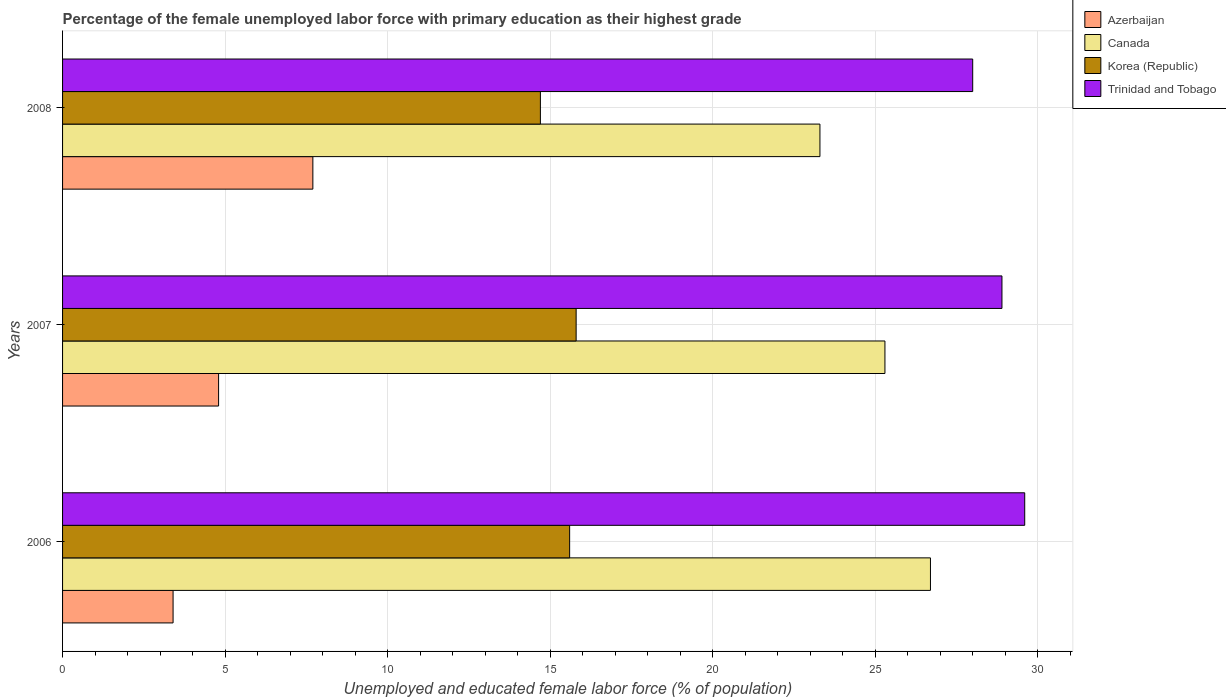Are the number of bars on each tick of the Y-axis equal?
Offer a terse response. Yes. What is the label of the 2nd group of bars from the top?
Keep it short and to the point. 2007. What is the percentage of the unemployed female labor force with primary education in Azerbaijan in 2007?
Your answer should be very brief. 4.8. Across all years, what is the maximum percentage of the unemployed female labor force with primary education in Azerbaijan?
Your answer should be compact. 7.7. What is the total percentage of the unemployed female labor force with primary education in Canada in the graph?
Your answer should be very brief. 75.3. What is the difference between the percentage of the unemployed female labor force with primary education in Trinidad and Tobago in 2006 and that in 2008?
Your answer should be very brief. 1.6. What is the difference between the percentage of the unemployed female labor force with primary education in Trinidad and Tobago in 2006 and the percentage of the unemployed female labor force with primary education in Canada in 2007?
Make the answer very short. 4.3. What is the average percentage of the unemployed female labor force with primary education in Korea (Republic) per year?
Offer a very short reply. 15.37. In the year 2008, what is the difference between the percentage of the unemployed female labor force with primary education in Trinidad and Tobago and percentage of the unemployed female labor force with primary education in Korea (Republic)?
Your answer should be compact. 13.3. In how many years, is the percentage of the unemployed female labor force with primary education in Canada greater than 4 %?
Your answer should be very brief. 3. What is the ratio of the percentage of the unemployed female labor force with primary education in Azerbaijan in 2006 to that in 2008?
Your answer should be very brief. 0.44. What is the difference between the highest and the second highest percentage of the unemployed female labor force with primary education in Canada?
Your answer should be very brief. 1.4. What is the difference between the highest and the lowest percentage of the unemployed female labor force with primary education in Azerbaijan?
Ensure brevity in your answer.  4.3. In how many years, is the percentage of the unemployed female labor force with primary education in Azerbaijan greater than the average percentage of the unemployed female labor force with primary education in Azerbaijan taken over all years?
Provide a short and direct response. 1. Is the sum of the percentage of the unemployed female labor force with primary education in Canada in 2007 and 2008 greater than the maximum percentage of the unemployed female labor force with primary education in Azerbaijan across all years?
Provide a succinct answer. Yes. What does the 3rd bar from the top in 2008 represents?
Offer a terse response. Canada. How many bars are there?
Your response must be concise. 12. Are all the bars in the graph horizontal?
Provide a succinct answer. Yes. Does the graph contain any zero values?
Provide a short and direct response. No. Where does the legend appear in the graph?
Your answer should be compact. Top right. How many legend labels are there?
Keep it short and to the point. 4. What is the title of the graph?
Your answer should be compact. Percentage of the female unemployed labor force with primary education as their highest grade. Does "Grenada" appear as one of the legend labels in the graph?
Offer a terse response. No. What is the label or title of the X-axis?
Make the answer very short. Unemployed and educated female labor force (% of population). What is the label or title of the Y-axis?
Your answer should be compact. Years. What is the Unemployed and educated female labor force (% of population) in Azerbaijan in 2006?
Keep it short and to the point. 3.4. What is the Unemployed and educated female labor force (% of population) of Canada in 2006?
Give a very brief answer. 26.7. What is the Unemployed and educated female labor force (% of population) in Korea (Republic) in 2006?
Your response must be concise. 15.6. What is the Unemployed and educated female labor force (% of population) in Trinidad and Tobago in 2006?
Offer a very short reply. 29.6. What is the Unemployed and educated female labor force (% of population) in Azerbaijan in 2007?
Ensure brevity in your answer.  4.8. What is the Unemployed and educated female labor force (% of population) in Canada in 2007?
Offer a terse response. 25.3. What is the Unemployed and educated female labor force (% of population) in Korea (Republic) in 2007?
Provide a succinct answer. 15.8. What is the Unemployed and educated female labor force (% of population) of Trinidad and Tobago in 2007?
Your answer should be compact. 28.9. What is the Unemployed and educated female labor force (% of population) in Azerbaijan in 2008?
Your answer should be very brief. 7.7. What is the Unemployed and educated female labor force (% of population) of Canada in 2008?
Provide a succinct answer. 23.3. What is the Unemployed and educated female labor force (% of population) of Korea (Republic) in 2008?
Your answer should be very brief. 14.7. What is the Unemployed and educated female labor force (% of population) in Trinidad and Tobago in 2008?
Keep it short and to the point. 28. Across all years, what is the maximum Unemployed and educated female labor force (% of population) in Azerbaijan?
Your answer should be very brief. 7.7. Across all years, what is the maximum Unemployed and educated female labor force (% of population) in Canada?
Offer a terse response. 26.7. Across all years, what is the maximum Unemployed and educated female labor force (% of population) of Korea (Republic)?
Make the answer very short. 15.8. Across all years, what is the maximum Unemployed and educated female labor force (% of population) of Trinidad and Tobago?
Offer a very short reply. 29.6. Across all years, what is the minimum Unemployed and educated female labor force (% of population) in Azerbaijan?
Make the answer very short. 3.4. Across all years, what is the minimum Unemployed and educated female labor force (% of population) of Canada?
Make the answer very short. 23.3. Across all years, what is the minimum Unemployed and educated female labor force (% of population) in Korea (Republic)?
Provide a short and direct response. 14.7. Across all years, what is the minimum Unemployed and educated female labor force (% of population) of Trinidad and Tobago?
Ensure brevity in your answer.  28. What is the total Unemployed and educated female labor force (% of population) in Canada in the graph?
Provide a short and direct response. 75.3. What is the total Unemployed and educated female labor force (% of population) of Korea (Republic) in the graph?
Provide a succinct answer. 46.1. What is the total Unemployed and educated female labor force (% of population) of Trinidad and Tobago in the graph?
Provide a short and direct response. 86.5. What is the difference between the Unemployed and educated female labor force (% of population) of Canada in 2006 and that in 2007?
Offer a terse response. 1.4. What is the difference between the Unemployed and educated female labor force (% of population) in Korea (Republic) in 2006 and that in 2007?
Ensure brevity in your answer.  -0.2. What is the difference between the Unemployed and educated female labor force (% of population) of Trinidad and Tobago in 2006 and that in 2007?
Ensure brevity in your answer.  0.7. What is the difference between the Unemployed and educated female labor force (% of population) of Azerbaijan in 2006 and that in 2008?
Keep it short and to the point. -4.3. What is the difference between the Unemployed and educated female labor force (% of population) in Canada in 2006 and that in 2008?
Give a very brief answer. 3.4. What is the difference between the Unemployed and educated female labor force (% of population) in Azerbaijan in 2007 and that in 2008?
Ensure brevity in your answer.  -2.9. What is the difference between the Unemployed and educated female labor force (% of population) of Canada in 2007 and that in 2008?
Provide a succinct answer. 2. What is the difference between the Unemployed and educated female labor force (% of population) in Azerbaijan in 2006 and the Unemployed and educated female labor force (% of population) in Canada in 2007?
Your answer should be very brief. -21.9. What is the difference between the Unemployed and educated female labor force (% of population) in Azerbaijan in 2006 and the Unemployed and educated female labor force (% of population) in Trinidad and Tobago in 2007?
Provide a short and direct response. -25.5. What is the difference between the Unemployed and educated female labor force (% of population) of Canada in 2006 and the Unemployed and educated female labor force (% of population) of Korea (Republic) in 2007?
Make the answer very short. 10.9. What is the difference between the Unemployed and educated female labor force (% of population) in Canada in 2006 and the Unemployed and educated female labor force (% of population) in Trinidad and Tobago in 2007?
Your answer should be very brief. -2.2. What is the difference between the Unemployed and educated female labor force (% of population) of Korea (Republic) in 2006 and the Unemployed and educated female labor force (% of population) of Trinidad and Tobago in 2007?
Provide a succinct answer. -13.3. What is the difference between the Unemployed and educated female labor force (% of population) of Azerbaijan in 2006 and the Unemployed and educated female labor force (% of population) of Canada in 2008?
Offer a terse response. -19.9. What is the difference between the Unemployed and educated female labor force (% of population) of Azerbaijan in 2006 and the Unemployed and educated female labor force (% of population) of Korea (Republic) in 2008?
Keep it short and to the point. -11.3. What is the difference between the Unemployed and educated female labor force (% of population) of Azerbaijan in 2006 and the Unemployed and educated female labor force (% of population) of Trinidad and Tobago in 2008?
Your answer should be compact. -24.6. What is the difference between the Unemployed and educated female labor force (% of population) in Canada in 2006 and the Unemployed and educated female labor force (% of population) in Korea (Republic) in 2008?
Keep it short and to the point. 12. What is the difference between the Unemployed and educated female labor force (% of population) of Korea (Republic) in 2006 and the Unemployed and educated female labor force (% of population) of Trinidad and Tobago in 2008?
Ensure brevity in your answer.  -12.4. What is the difference between the Unemployed and educated female labor force (% of population) in Azerbaijan in 2007 and the Unemployed and educated female labor force (% of population) in Canada in 2008?
Offer a terse response. -18.5. What is the difference between the Unemployed and educated female labor force (% of population) in Azerbaijan in 2007 and the Unemployed and educated female labor force (% of population) in Trinidad and Tobago in 2008?
Make the answer very short. -23.2. What is the difference between the Unemployed and educated female labor force (% of population) in Canada in 2007 and the Unemployed and educated female labor force (% of population) in Korea (Republic) in 2008?
Ensure brevity in your answer.  10.6. What is the difference between the Unemployed and educated female labor force (% of population) in Canada in 2007 and the Unemployed and educated female labor force (% of population) in Trinidad and Tobago in 2008?
Give a very brief answer. -2.7. What is the difference between the Unemployed and educated female labor force (% of population) in Korea (Republic) in 2007 and the Unemployed and educated female labor force (% of population) in Trinidad and Tobago in 2008?
Provide a succinct answer. -12.2. What is the average Unemployed and educated female labor force (% of population) in Canada per year?
Keep it short and to the point. 25.1. What is the average Unemployed and educated female labor force (% of population) of Korea (Republic) per year?
Keep it short and to the point. 15.37. What is the average Unemployed and educated female labor force (% of population) in Trinidad and Tobago per year?
Offer a very short reply. 28.83. In the year 2006, what is the difference between the Unemployed and educated female labor force (% of population) in Azerbaijan and Unemployed and educated female labor force (% of population) in Canada?
Your response must be concise. -23.3. In the year 2006, what is the difference between the Unemployed and educated female labor force (% of population) in Azerbaijan and Unemployed and educated female labor force (% of population) in Trinidad and Tobago?
Keep it short and to the point. -26.2. In the year 2006, what is the difference between the Unemployed and educated female labor force (% of population) of Canada and Unemployed and educated female labor force (% of population) of Trinidad and Tobago?
Give a very brief answer. -2.9. In the year 2006, what is the difference between the Unemployed and educated female labor force (% of population) of Korea (Republic) and Unemployed and educated female labor force (% of population) of Trinidad and Tobago?
Offer a terse response. -14. In the year 2007, what is the difference between the Unemployed and educated female labor force (% of population) of Azerbaijan and Unemployed and educated female labor force (% of population) of Canada?
Your answer should be very brief. -20.5. In the year 2007, what is the difference between the Unemployed and educated female labor force (% of population) in Azerbaijan and Unemployed and educated female labor force (% of population) in Trinidad and Tobago?
Offer a very short reply. -24.1. In the year 2007, what is the difference between the Unemployed and educated female labor force (% of population) in Korea (Republic) and Unemployed and educated female labor force (% of population) in Trinidad and Tobago?
Provide a succinct answer. -13.1. In the year 2008, what is the difference between the Unemployed and educated female labor force (% of population) in Azerbaijan and Unemployed and educated female labor force (% of population) in Canada?
Offer a very short reply. -15.6. In the year 2008, what is the difference between the Unemployed and educated female labor force (% of population) of Azerbaijan and Unemployed and educated female labor force (% of population) of Korea (Republic)?
Keep it short and to the point. -7. In the year 2008, what is the difference between the Unemployed and educated female labor force (% of population) in Azerbaijan and Unemployed and educated female labor force (% of population) in Trinidad and Tobago?
Ensure brevity in your answer.  -20.3. In the year 2008, what is the difference between the Unemployed and educated female labor force (% of population) of Canada and Unemployed and educated female labor force (% of population) of Trinidad and Tobago?
Give a very brief answer. -4.7. What is the ratio of the Unemployed and educated female labor force (% of population) of Azerbaijan in 2006 to that in 2007?
Your answer should be very brief. 0.71. What is the ratio of the Unemployed and educated female labor force (% of population) in Canada in 2006 to that in 2007?
Your answer should be compact. 1.06. What is the ratio of the Unemployed and educated female labor force (% of population) of Korea (Republic) in 2006 to that in 2007?
Make the answer very short. 0.99. What is the ratio of the Unemployed and educated female labor force (% of population) of Trinidad and Tobago in 2006 to that in 2007?
Your response must be concise. 1.02. What is the ratio of the Unemployed and educated female labor force (% of population) in Azerbaijan in 2006 to that in 2008?
Your answer should be very brief. 0.44. What is the ratio of the Unemployed and educated female labor force (% of population) in Canada in 2006 to that in 2008?
Ensure brevity in your answer.  1.15. What is the ratio of the Unemployed and educated female labor force (% of population) of Korea (Republic) in 2006 to that in 2008?
Your response must be concise. 1.06. What is the ratio of the Unemployed and educated female labor force (% of population) in Trinidad and Tobago in 2006 to that in 2008?
Your answer should be compact. 1.06. What is the ratio of the Unemployed and educated female labor force (% of population) of Azerbaijan in 2007 to that in 2008?
Keep it short and to the point. 0.62. What is the ratio of the Unemployed and educated female labor force (% of population) of Canada in 2007 to that in 2008?
Your answer should be compact. 1.09. What is the ratio of the Unemployed and educated female labor force (% of population) of Korea (Republic) in 2007 to that in 2008?
Offer a terse response. 1.07. What is the ratio of the Unemployed and educated female labor force (% of population) of Trinidad and Tobago in 2007 to that in 2008?
Offer a very short reply. 1.03. What is the difference between the highest and the second highest Unemployed and educated female labor force (% of population) in Azerbaijan?
Keep it short and to the point. 2.9. What is the difference between the highest and the second highest Unemployed and educated female labor force (% of population) in Canada?
Your answer should be very brief. 1.4. What is the difference between the highest and the lowest Unemployed and educated female labor force (% of population) in Azerbaijan?
Offer a terse response. 4.3. What is the difference between the highest and the lowest Unemployed and educated female labor force (% of population) in Korea (Republic)?
Ensure brevity in your answer.  1.1. What is the difference between the highest and the lowest Unemployed and educated female labor force (% of population) of Trinidad and Tobago?
Give a very brief answer. 1.6. 